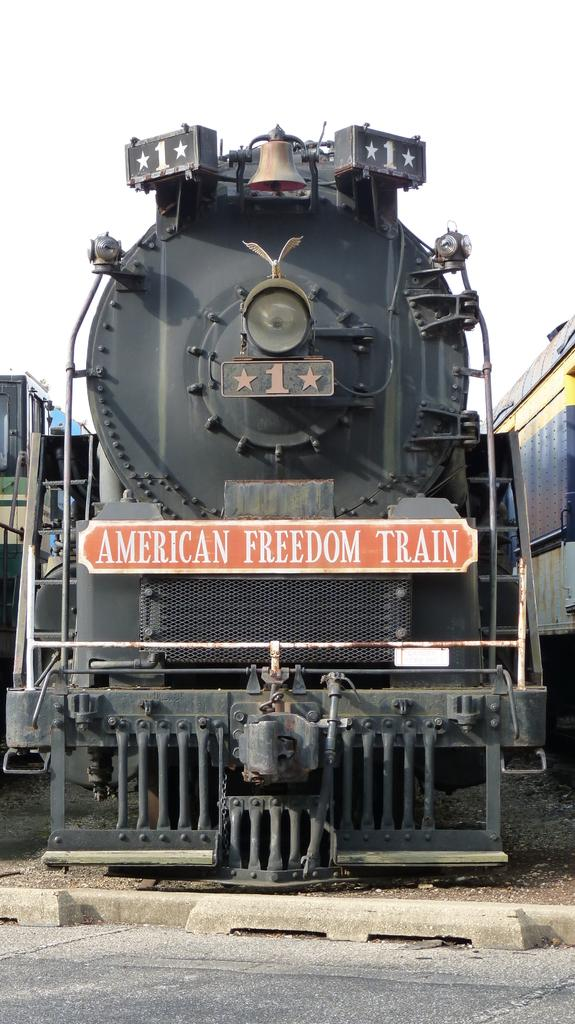What is the main subject of the image? The main subject of the image is a train. What else can be seen in the image besides the train? There is a board with text and a train bell visible in the image. How many dogs are sitting on the train in the image? There are no dogs present in the image; it features a train, a board with text, and a train bell. 